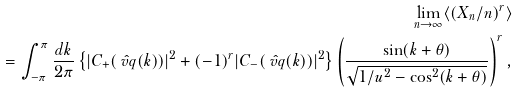<formula> <loc_0><loc_0><loc_500><loc_500>\lim _ { n \to \infty } \langle ( X _ { n } / n ) ^ { r } \rangle \\ = \int _ { - \pi } ^ { \pi } \frac { d k } { 2 \pi } \left \{ | C _ { + } ( \hat { \ v q } ( k ) ) | ^ { 2 } + ( - 1 ) ^ { r } | C _ { - } ( \hat { \ v q } ( k ) ) | ^ { 2 } \right \} \left ( \frac { \sin ( k + \theta ) } { \sqrt { 1 / u ^ { 2 } - \cos ^ { 2 } ( k + \theta ) } } \right ) ^ { r } ,</formula> 